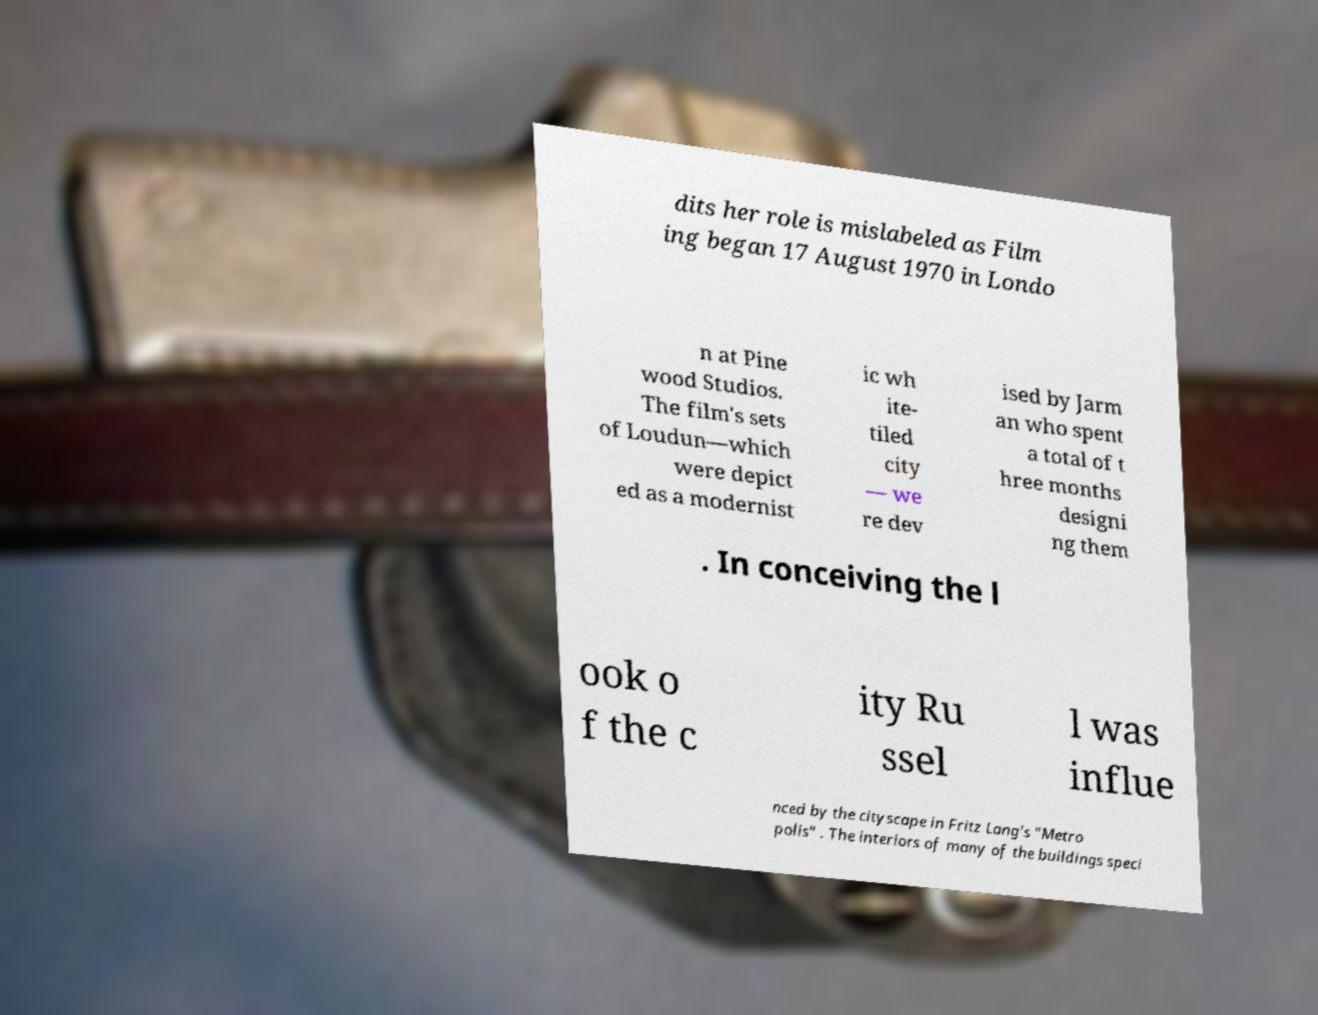There's text embedded in this image that I need extracted. Can you transcribe it verbatim? dits her role is mislabeled as Film ing began 17 August 1970 in Londo n at Pine wood Studios. The film's sets of Loudun—which were depict ed as a modernist ic wh ite- tiled city — we re dev ised by Jarm an who spent a total of t hree months designi ng them . In conceiving the l ook o f the c ity Ru ssel l was influe nced by the cityscape in Fritz Lang's "Metro polis" . The interiors of many of the buildings speci 